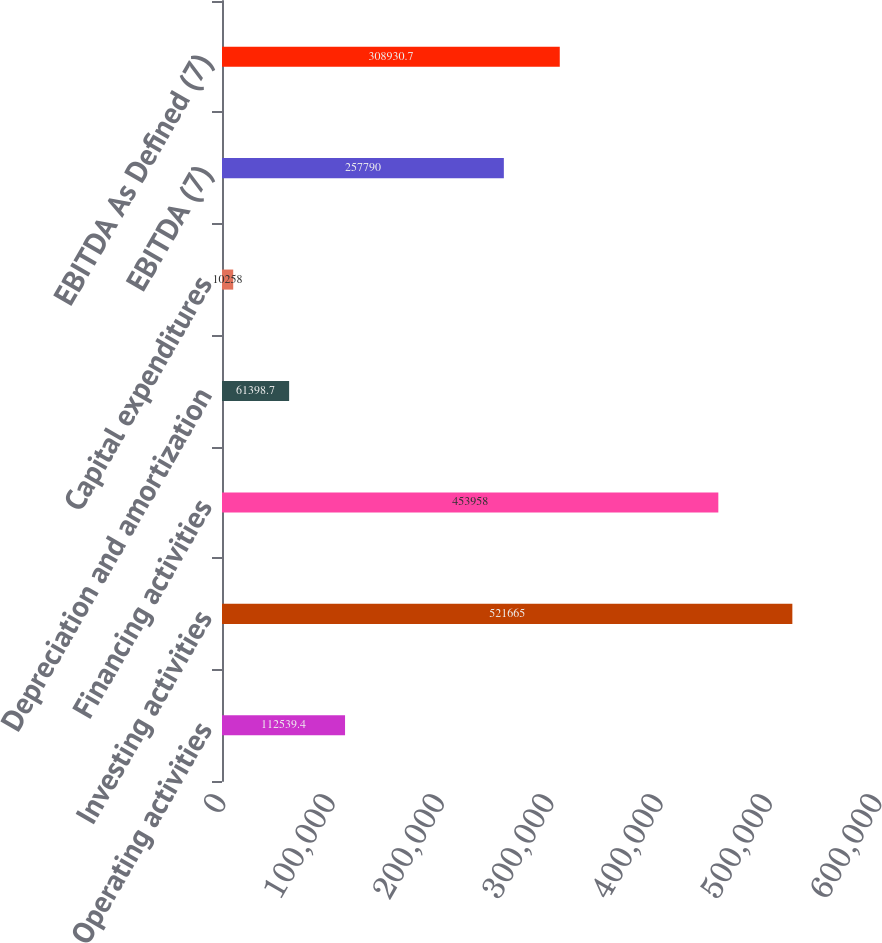Convert chart. <chart><loc_0><loc_0><loc_500><loc_500><bar_chart><fcel>Operating activities<fcel>Investing activities<fcel>Financing activities<fcel>Depreciation and amortization<fcel>Capital expenditures<fcel>EBITDA (7)<fcel>EBITDA As Defined (7)<nl><fcel>112539<fcel>521665<fcel>453958<fcel>61398.7<fcel>10258<fcel>257790<fcel>308931<nl></chart> 